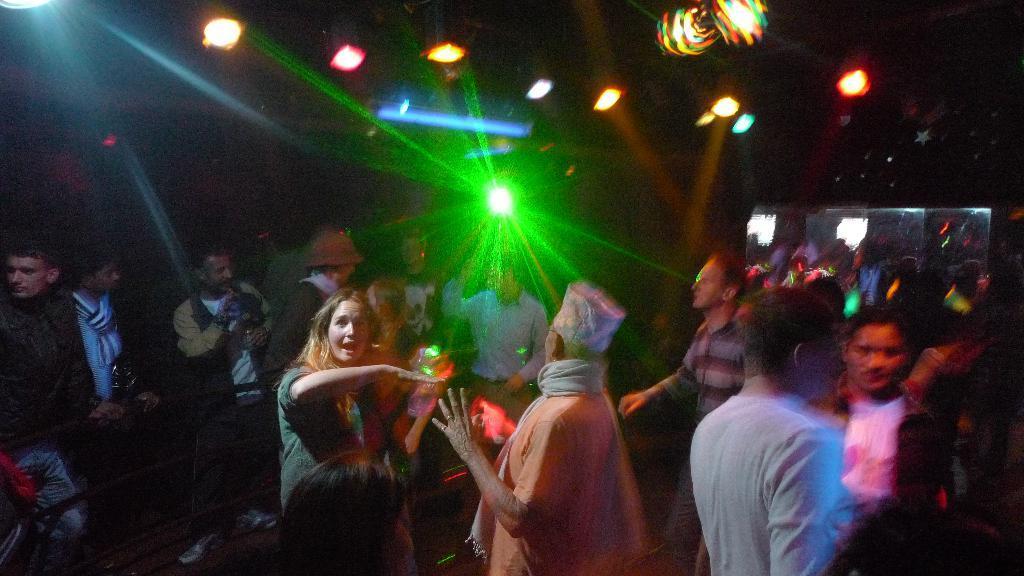Please provide a concise description of this image. In this image, we can see people and some are performing dance. In the background, we can see lights. 